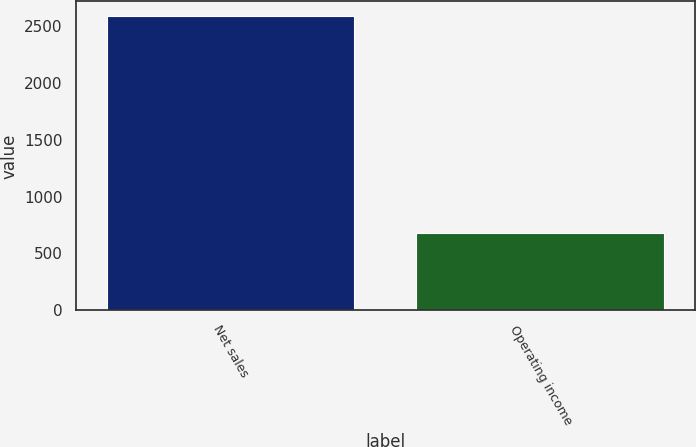Convert chart to OTSL. <chart><loc_0><loc_0><loc_500><loc_500><bar_chart><fcel>Net sales<fcel>Operating income<nl><fcel>2589<fcel>682<nl></chart> 